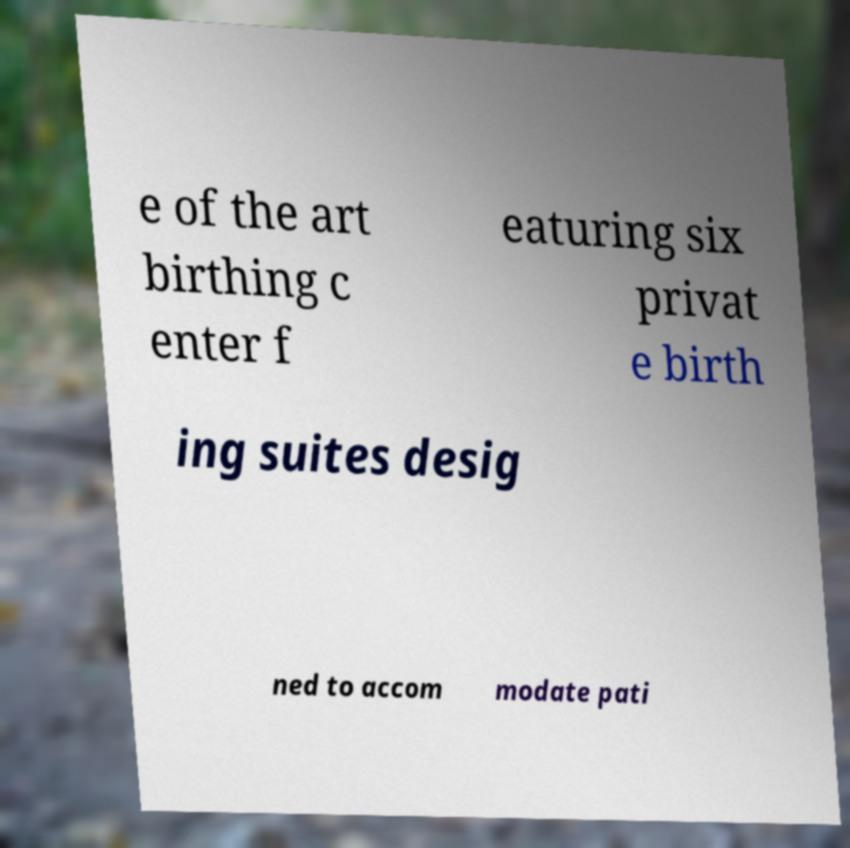Could you extract and type out the text from this image? e of the art birthing c enter f eaturing six privat e birth ing suites desig ned to accom modate pati 